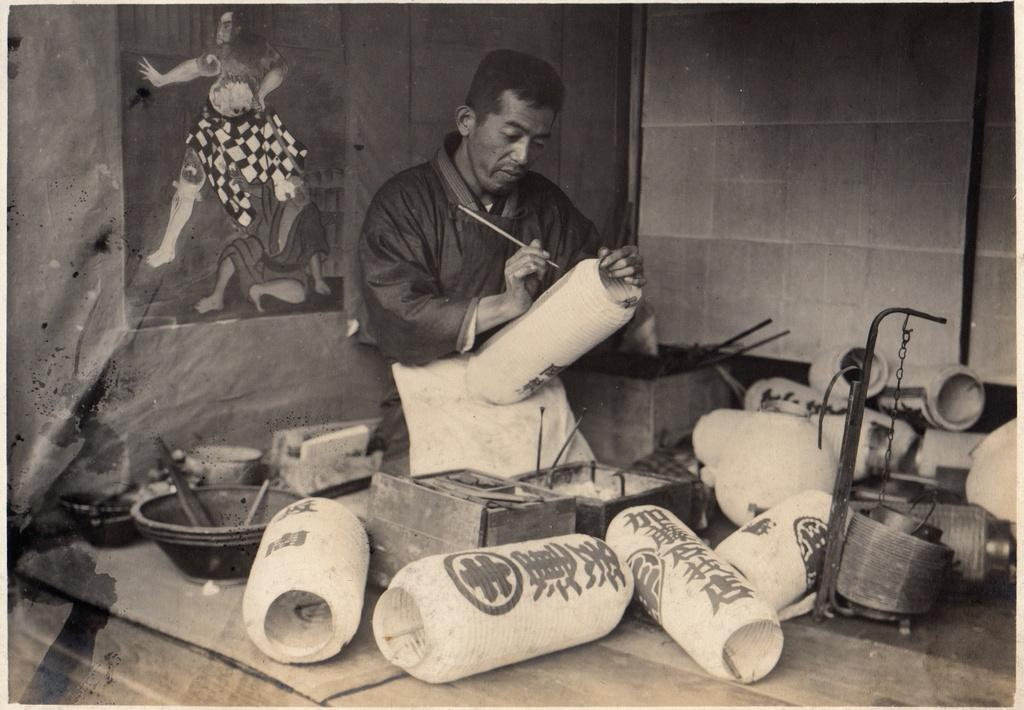What is the man in the image holding in his hand? The man is holding a brush and a jar in the image. What can be seen behind the man in the image? There is a poster visible behind the man in the image. What other items are present in front of the man? There are additional jars and brushes in front of the man. Can you see the man skating in the image? No, the man is not skating in the image; he is holding a brush and a jar. Is there a camp visible in the image? No, there is no camp present in the image; only the man, the brush, the jar, the poster, and additional jars and brushes are visible. 